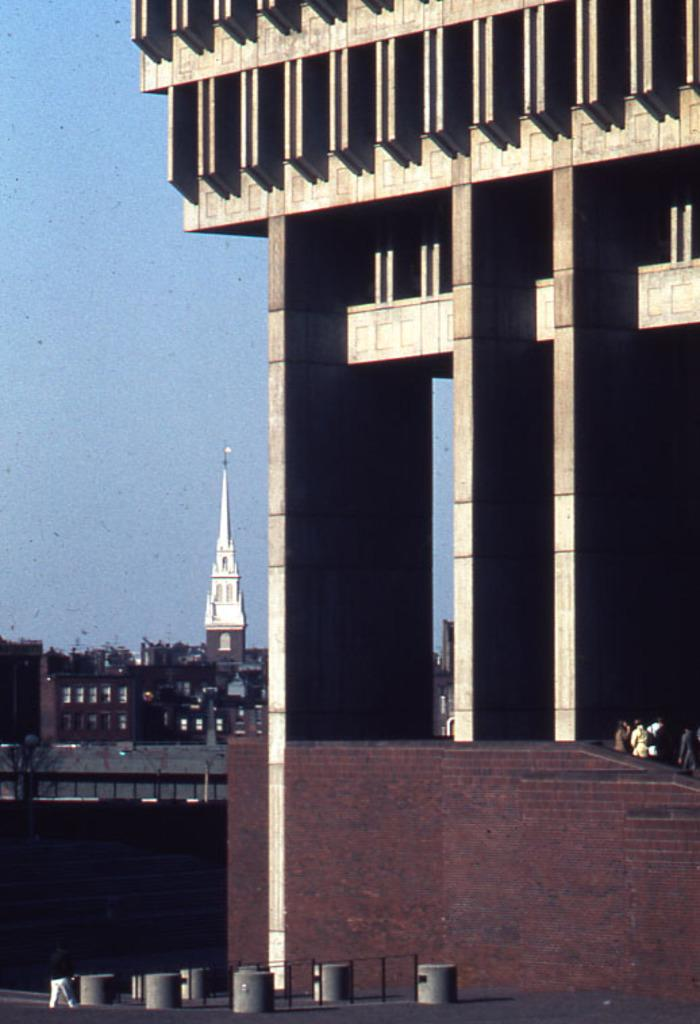What type of structures can be seen in the image? There are buildings in the image. Where are the persons located in the image? The persons are standing behind a wall on the right side of the image. What part of the natural environment is visible in the image? Sky is visible on the left side of the image. What type of jam is being spread on the cracker in the image? There is no jam or cracker present in the image. How many crows are visible in the image? There are no crows visible in the image. 